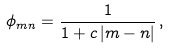Convert formula to latex. <formula><loc_0><loc_0><loc_500><loc_500>\phi _ { m n } = \frac { 1 } { 1 + c \, | m - n | } \, ,</formula> 